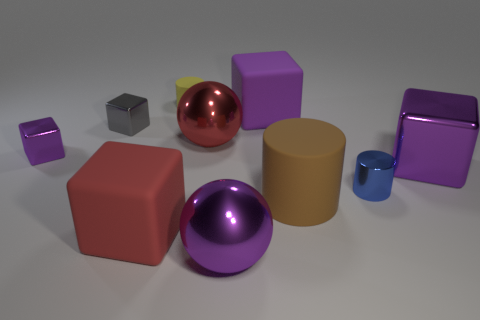Subtract all gray balls. How many purple blocks are left? 3 Subtract all purple rubber cubes. How many cubes are left? 4 Subtract all blue blocks. Subtract all blue cylinders. How many blocks are left? 5 Subtract all cylinders. How many objects are left? 7 Add 9 big brown rubber things. How many big brown rubber things are left? 10 Add 2 big cylinders. How many big cylinders exist? 3 Subtract 3 purple cubes. How many objects are left? 7 Subtract all metal blocks. Subtract all gray metal things. How many objects are left? 6 